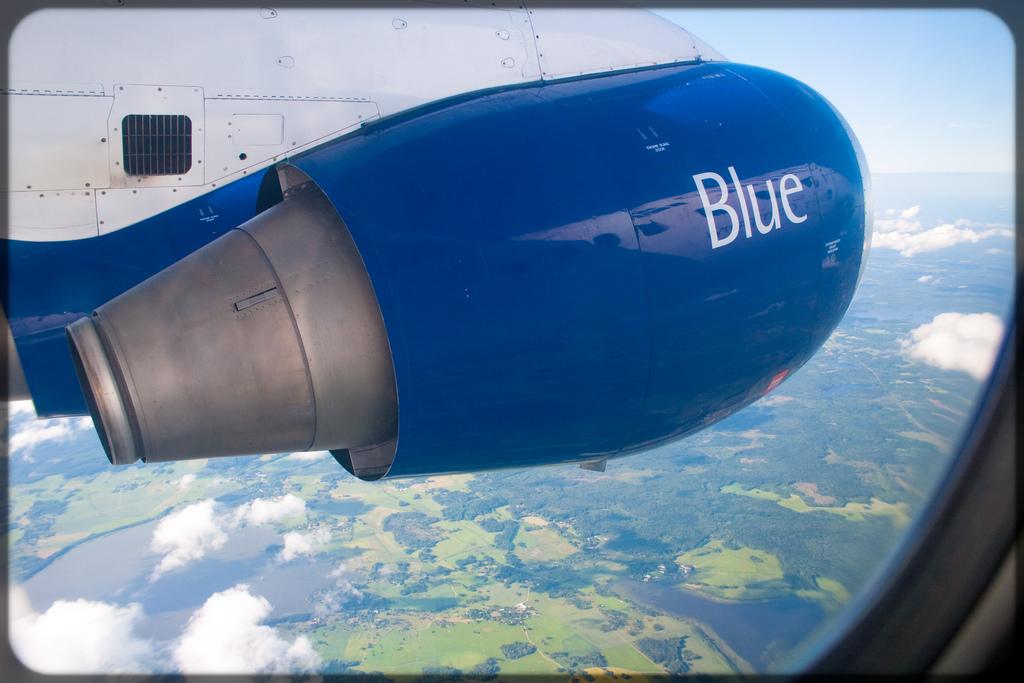Is that the blue plane?
Your answer should be compact. Yes. 